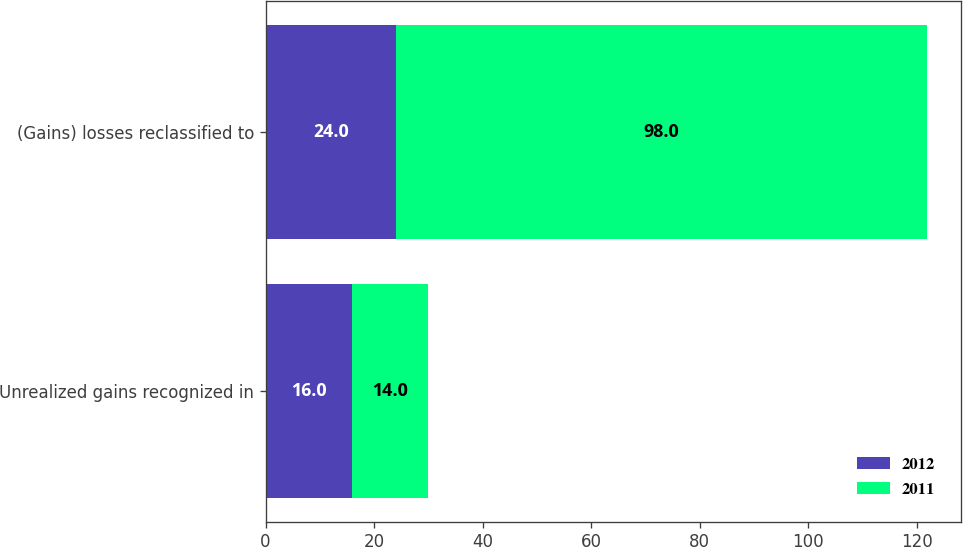Convert chart to OTSL. <chart><loc_0><loc_0><loc_500><loc_500><stacked_bar_chart><ecel><fcel>Unrealized gains recognized in<fcel>(Gains) losses reclassified to<nl><fcel>2012<fcel>16<fcel>24<nl><fcel>2011<fcel>14<fcel>98<nl></chart> 